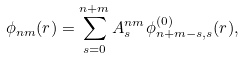<formula> <loc_0><loc_0><loc_500><loc_500>\phi _ { n m } ( r ) = \sum _ { s = 0 } ^ { n + m } A _ { s } ^ { n m } \phi ^ { ( 0 ) } _ { n + m - s , s } ( r ) ,</formula> 